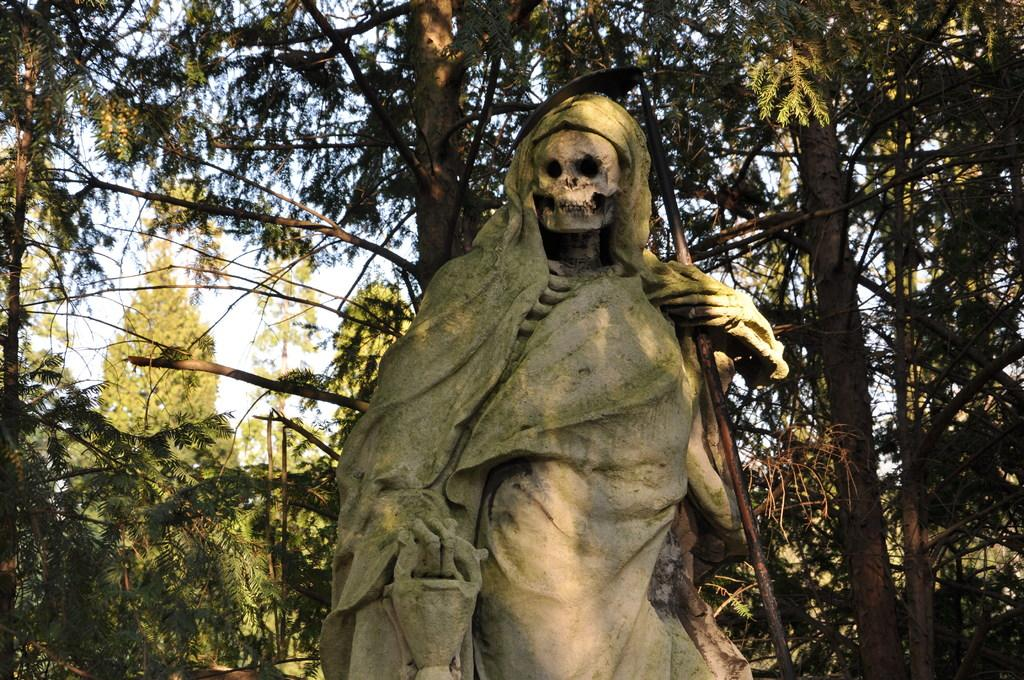What is the main subject of the image? There is a sculpture in the image. What can be seen in the background of the image? There are trees and the sky visible in the background of the image. Can you see a stream flowing near the sculpture in the image? There is no stream visible in the image; it only features a sculpture and the background with trees and the sky. 